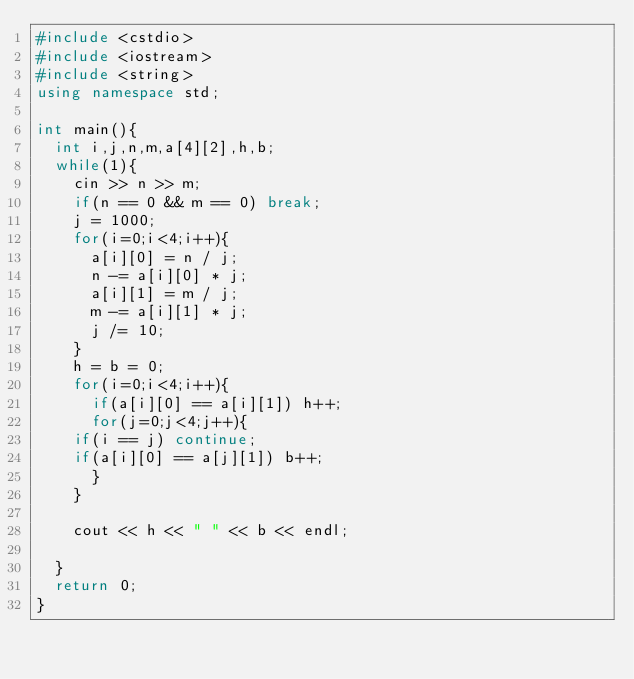<code> <loc_0><loc_0><loc_500><loc_500><_C++_>#include <cstdio>
#include <iostream>
#include <string>
using namespace std;

int main(){
  int i,j,n,m,a[4][2],h,b;
  while(1){
    cin >> n >> m;
    if(n == 0 && m == 0) break;
    j = 1000;
    for(i=0;i<4;i++){
      a[i][0] = n / j;
      n -= a[i][0] * j;
      a[i][1] = m / j;
      m -= a[i][1] * j;
      j /= 10;
    }
    h = b = 0;
    for(i=0;i<4;i++){
      if(a[i][0] == a[i][1]) h++;
      for(j=0;j<4;j++){
	if(i == j) continue;
	if(a[i][0] == a[j][1]) b++;
      }
    }

    cout << h << " " << b << endl;

  }
  return 0;
}</code> 